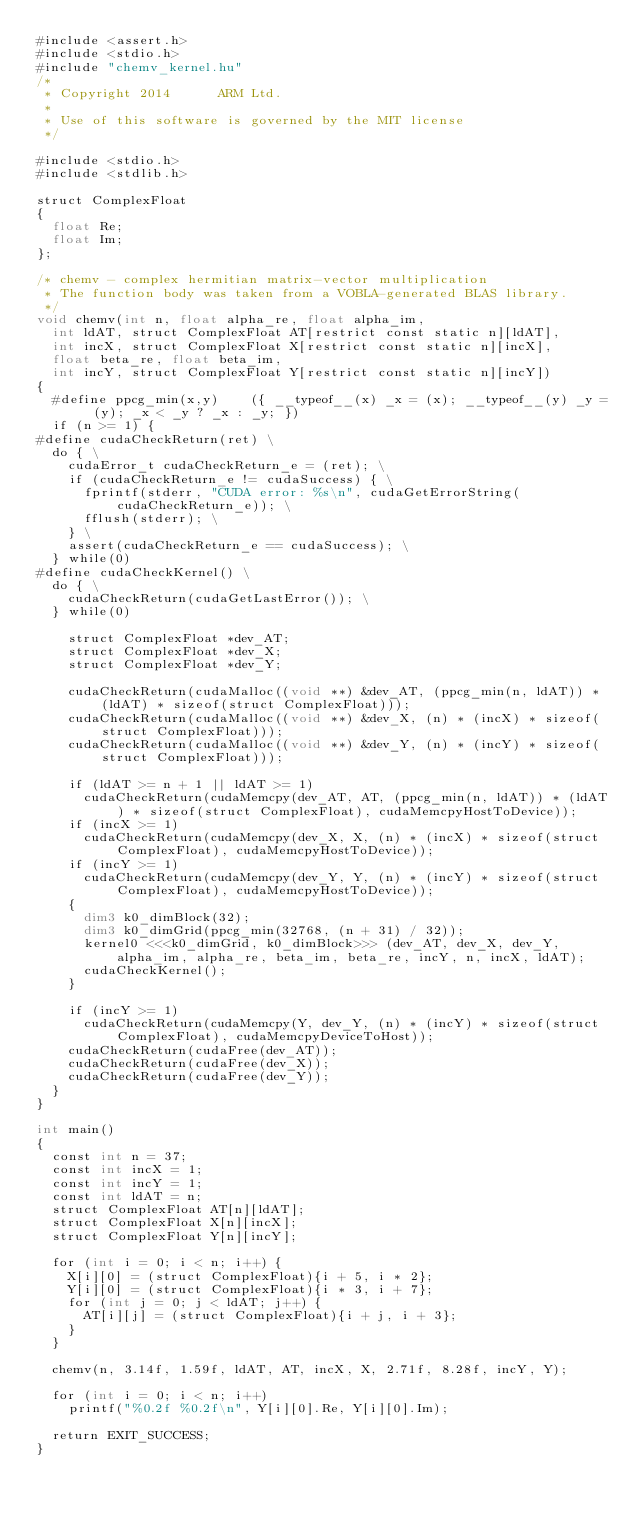Convert code to text. <code><loc_0><loc_0><loc_500><loc_500><_Cuda_>#include <assert.h>
#include <stdio.h>
#include "chemv_kernel.hu"
/*
 * Copyright 2014      ARM Ltd.
 *
 * Use of this software is governed by the MIT license
 */

#include <stdio.h>
#include <stdlib.h>

struct ComplexFloat
{
	float Re;
	float Im;
};

/* chemv - complex hermitian matrix-vector multiplication
 * The function body was taken from a VOBLA-generated BLAS library.
 */
void chemv(int n, float alpha_re, float alpha_im,
	int ldAT, struct ComplexFloat AT[restrict const static n][ldAT],
	int incX, struct ComplexFloat X[restrict const static n][incX],
	float beta_re, float beta_im,
	int incY, struct ComplexFloat Y[restrict const static n][incY])
{
	#define ppcg_min(x,y)    ({ __typeof__(x) _x = (x); __typeof__(y) _y = (y); _x < _y ? _x : _y; })
	if (n >= 1) {
#define cudaCheckReturn(ret) \
  do { \
    cudaError_t cudaCheckReturn_e = (ret); \
    if (cudaCheckReturn_e != cudaSuccess) { \
      fprintf(stderr, "CUDA error: %s\n", cudaGetErrorString(cudaCheckReturn_e)); \
      fflush(stderr); \
    } \
    assert(cudaCheckReturn_e == cudaSuccess); \
  } while(0)
#define cudaCheckKernel() \
  do { \
    cudaCheckReturn(cudaGetLastError()); \
  } while(0)

	  struct ComplexFloat *dev_AT;
	  struct ComplexFloat *dev_X;
	  struct ComplexFloat *dev_Y;
	  
	  cudaCheckReturn(cudaMalloc((void **) &dev_AT, (ppcg_min(n, ldAT)) * (ldAT) * sizeof(struct ComplexFloat)));
	  cudaCheckReturn(cudaMalloc((void **) &dev_X, (n) * (incX) * sizeof(struct ComplexFloat)));
	  cudaCheckReturn(cudaMalloc((void **) &dev_Y, (n) * (incY) * sizeof(struct ComplexFloat)));
	  
	  if (ldAT >= n + 1 || ldAT >= 1)
	    cudaCheckReturn(cudaMemcpy(dev_AT, AT, (ppcg_min(n, ldAT)) * (ldAT) * sizeof(struct ComplexFloat), cudaMemcpyHostToDevice));
	  if (incX >= 1)
	    cudaCheckReturn(cudaMemcpy(dev_X, X, (n) * (incX) * sizeof(struct ComplexFloat), cudaMemcpyHostToDevice));
	  if (incY >= 1)
	    cudaCheckReturn(cudaMemcpy(dev_Y, Y, (n) * (incY) * sizeof(struct ComplexFloat), cudaMemcpyHostToDevice));
	  {
	    dim3 k0_dimBlock(32);
	    dim3 k0_dimGrid(ppcg_min(32768, (n + 31) / 32));
	    kernel0 <<<k0_dimGrid, k0_dimBlock>>> (dev_AT, dev_X, dev_Y, alpha_im, alpha_re, beta_im, beta_re, incY, n, incX, ldAT);
	    cudaCheckKernel();
	  }
	  
	  if (incY >= 1)
	    cudaCheckReturn(cudaMemcpy(Y, dev_Y, (n) * (incY) * sizeof(struct ComplexFloat), cudaMemcpyDeviceToHost));
	  cudaCheckReturn(cudaFree(dev_AT));
	  cudaCheckReturn(cudaFree(dev_X));
	  cudaCheckReturn(cudaFree(dev_Y));
	}
}

int main()
{
	const int n = 37;
	const int incX = 1;
	const int incY = 1;
	const int ldAT = n;
	struct ComplexFloat AT[n][ldAT];
	struct ComplexFloat X[n][incX];
	struct ComplexFloat Y[n][incY];

	for (int i = 0; i < n; i++) {
		X[i][0] = (struct ComplexFloat){i + 5, i * 2};
		Y[i][0] = (struct ComplexFloat){i * 3, i + 7};
		for (int j = 0; j < ldAT; j++) {
			AT[i][j] = (struct ComplexFloat){i + j, i + 3};
		}
	}

	chemv(n, 3.14f, 1.59f, ldAT, AT, incX, X, 2.71f, 8.28f, incY, Y);

	for (int i = 0; i < n; i++)
		printf("%0.2f %0.2f\n", Y[i][0].Re, Y[i][0].Im);

	return EXIT_SUCCESS;
}
</code> 